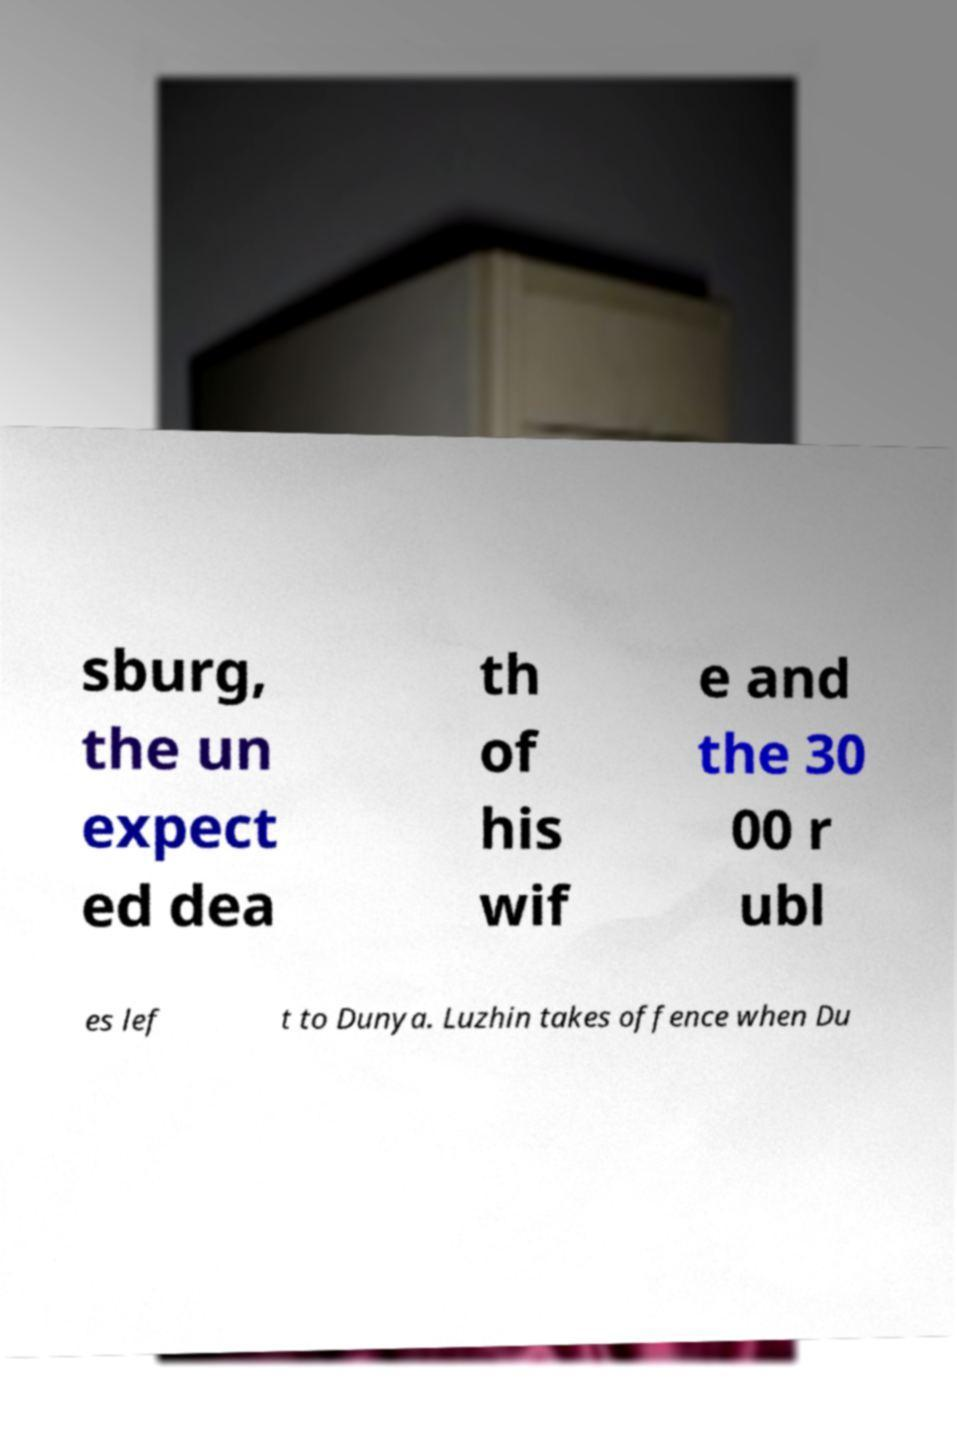For documentation purposes, I need the text within this image transcribed. Could you provide that? sburg, the un expect ed dea th of his wif e and the 30 00 r ubl es lef t to Dunya. Luzhin takes offence when Du 